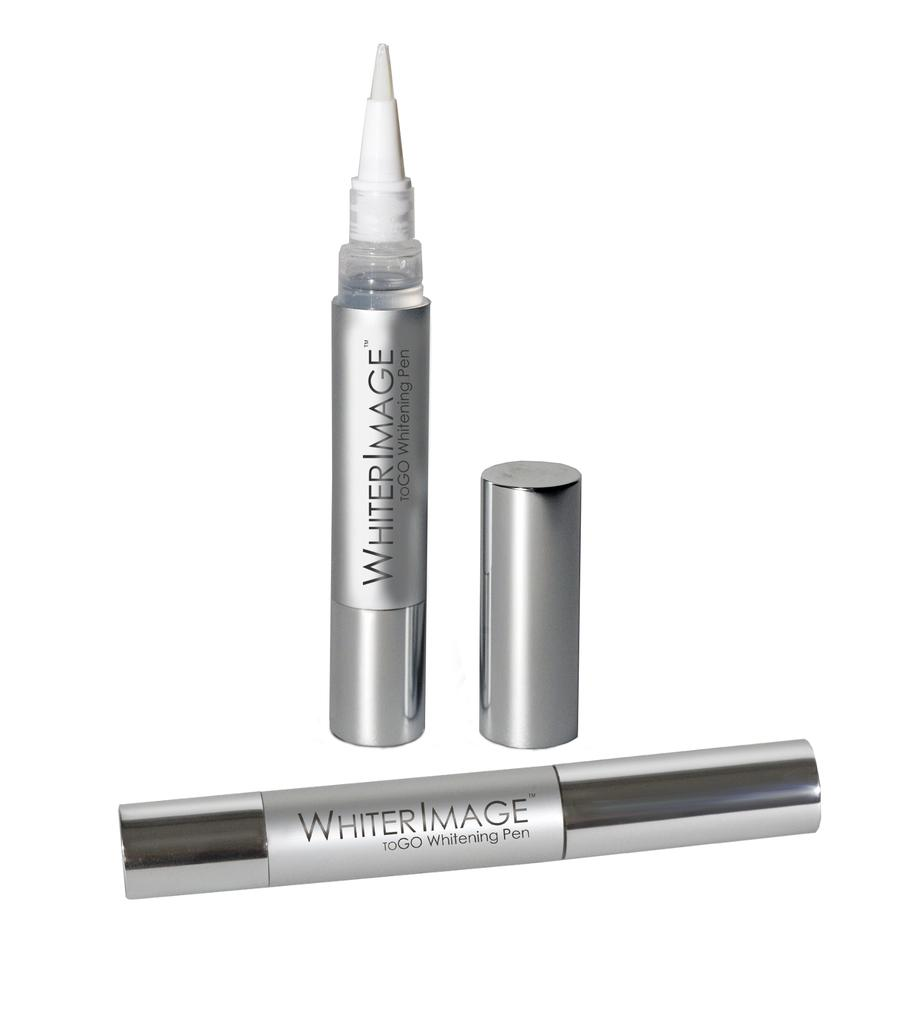<image>
Create a compact narrative representing the image presented. a display of Whiter Image Whitening Pen on a white background 